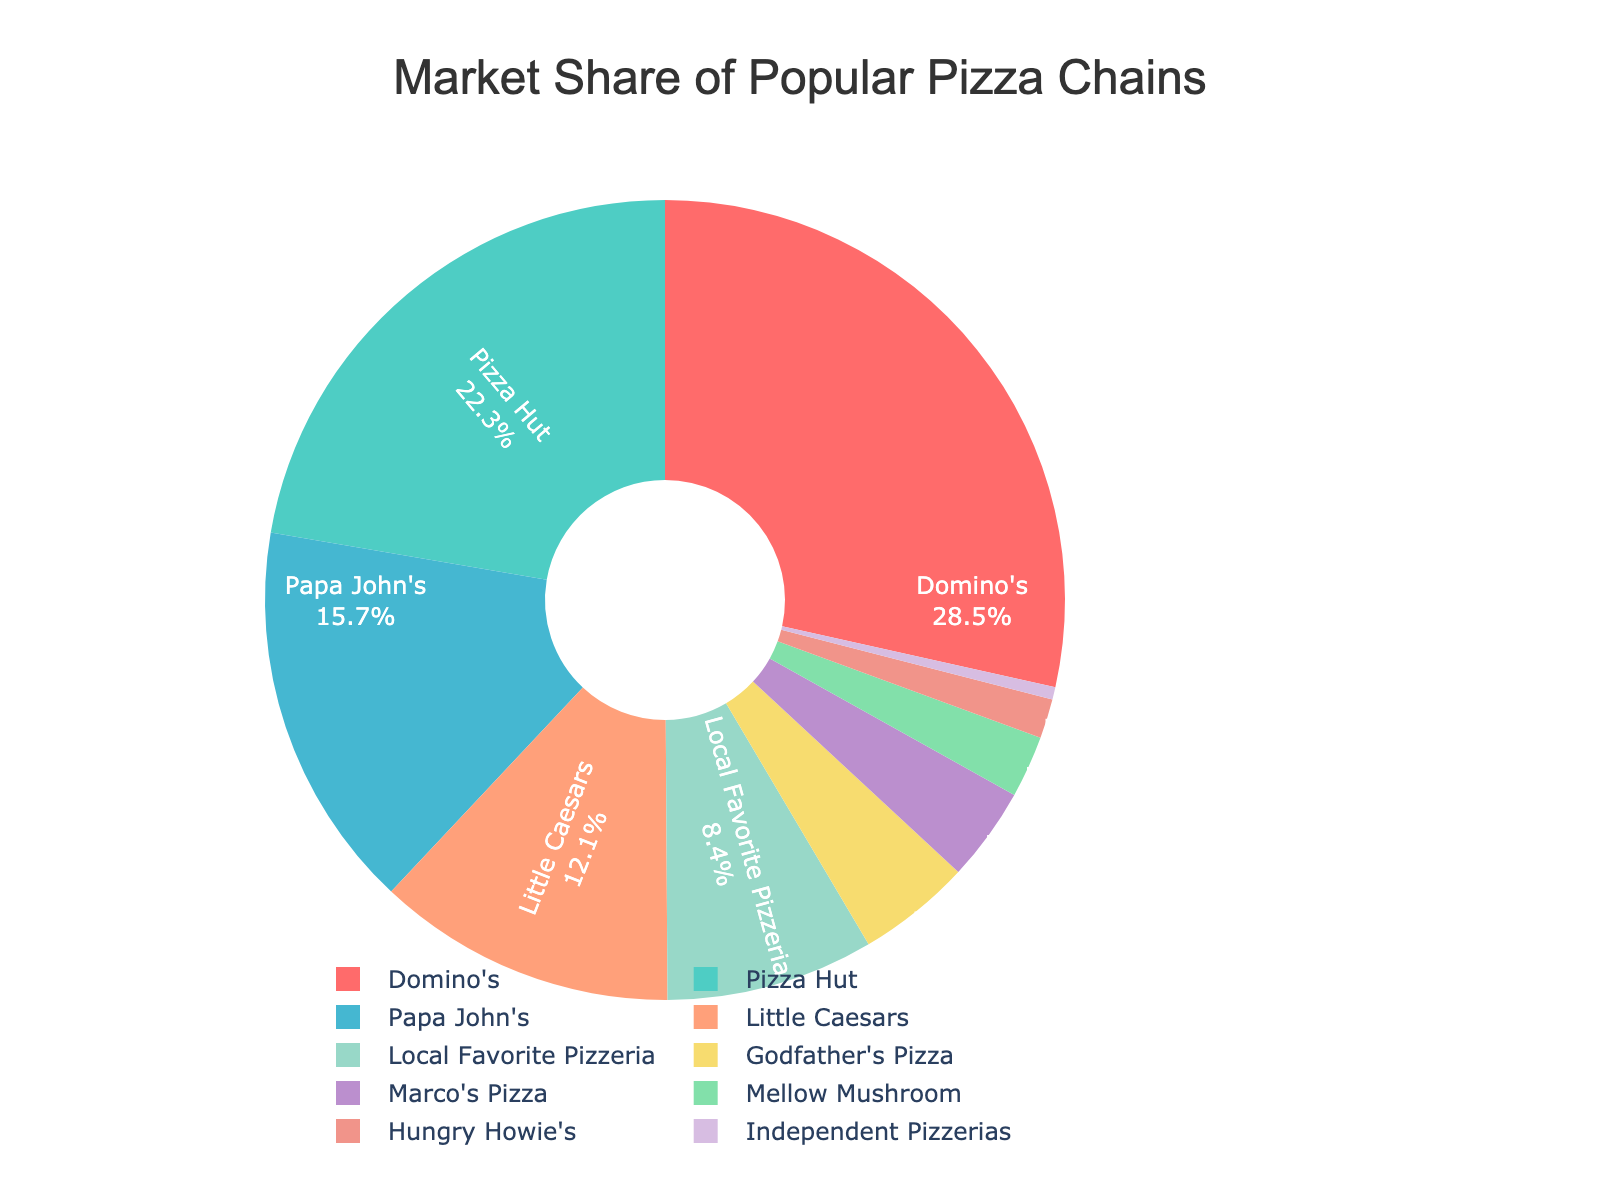What is the market share of the top two pizza chains combined? To find the combined market share of the top two pizza chains, add the market share of Domino's (28.5%) and Pizza Hut (22.3%). The calculation is 28.5 + 22.3 = 50.8.
Answer: 50.8% Which pizza chain has the smallest market share and what is it? The pizza chain with the smallest market share is Independent Pizzerias with 0.5%.
Answer: Independent Pizzerias, 0.5% What is the difference in market share between Papa John's and Little Caesars? To find the difference in market share, subtract Little Caesars' market share (12.1%) from Papa John's market share (15.7%). The calculation is 15.7 - 12.1 = 3.6.
Answer: 3.6% Which pizza chain has a larger market share, Local Favorite Pizzeria or Marco's Pizza, and by how much? Local Favorite Pizzeria has an 8.4% market share, while Marco's Pizza has a 3.8% market share. To find the difference, subtract Marco's market share from Local Favorite Pizzeria's market share. The calculation is 8.4 - 3.8 = 4.6.
Answer: Local Favorite Pizzeria by 4.6% What is the sum of the market shares of chains that have less than 5% market share each? Identify the chains with less than 5% market share: Godfather's Pizza (4.6%), Marco's Pizza (3.8%), Mellow Mushroom (2.5%), Hungry Howie's (1.6%), and Independent Pizzerias (0.5%). Sum these values: 4.6 + 3.8 + 2.5 + 1.6 + 0.5 = 13.0.
Answer: 13.0% How many pizza chains have a market share greater than 10%? Identify the chains with market shares greater than 10%: Domino's (28.5%), Pizza Hut (22.3%), Papa John's (15.7%), Little Caesars (12.1%). There are 4 pizza chains in this category.
Answer: 4 What is the average market share of Domino's, Pizza Hut, and Papa John's? To find the average, add the market shares of Domino's (28.5%), Pizza Hut (22.3%), and Papa John's (15.7%), then divide by 3. The calculation is (28.5 + 22.3 + 15.7) / 3 = 66.5 / 3 = 22.2.
Answer: 22.2% Which pizza chain is represented by the color blue in the pie chart? According to the color mapping provided, Pizza Hut is represented by the color blue in the pie chart.
Answer: Pizza Hut Is the market share of Little Caesars greater than the combined market share of Mellow Mushroom and Hungry Howie's? Compare the market share of Little Caesars (12.1%) with the combined market share of Mellow Mushroom (2.5%) and Hungry Howie's (1.6%). The combined market share of Mellow Mushroom and Hungry Howie's is 2.5 + 1.6 = 4.1. Since 12.1 > 4.1, the market share of Little Caesars is indeed greater.
Answer: Yes What percentage of the market do the chains other than Domino's, Pizza Hut, and Papa John's collectively hold? First, find the combined market share of Domino's, Pizza Hut, and Papa John's: 28.5 + 22.3 + 15.7 = 66.5. Then, subtract this from 100% to find the collective market share of the other chains: 100 - 66.5 = 33.5.
Answer: 33.5% 